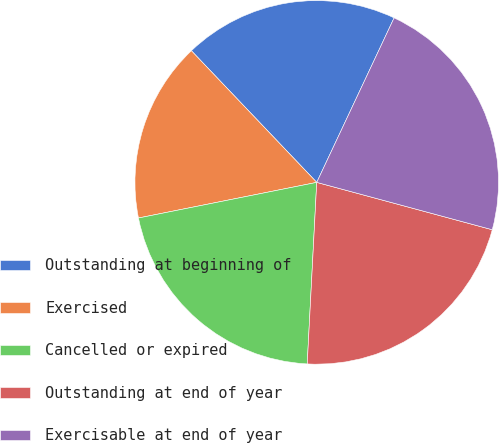Convert chart. <chart><loc_0><loc_0><loc_500><loc_500><pie_chart><fcel>Outstanding at beginning of<fcel>Exercised<fcel>Cancelled or expired<fcel>Outstanding at end of year<fcel>Exercisable at end of year<nl><fcel>19.11%<fcel>16.03%<fcel>21.03%<fcel>21.64%<fcel>22.2%<nl></chart> 